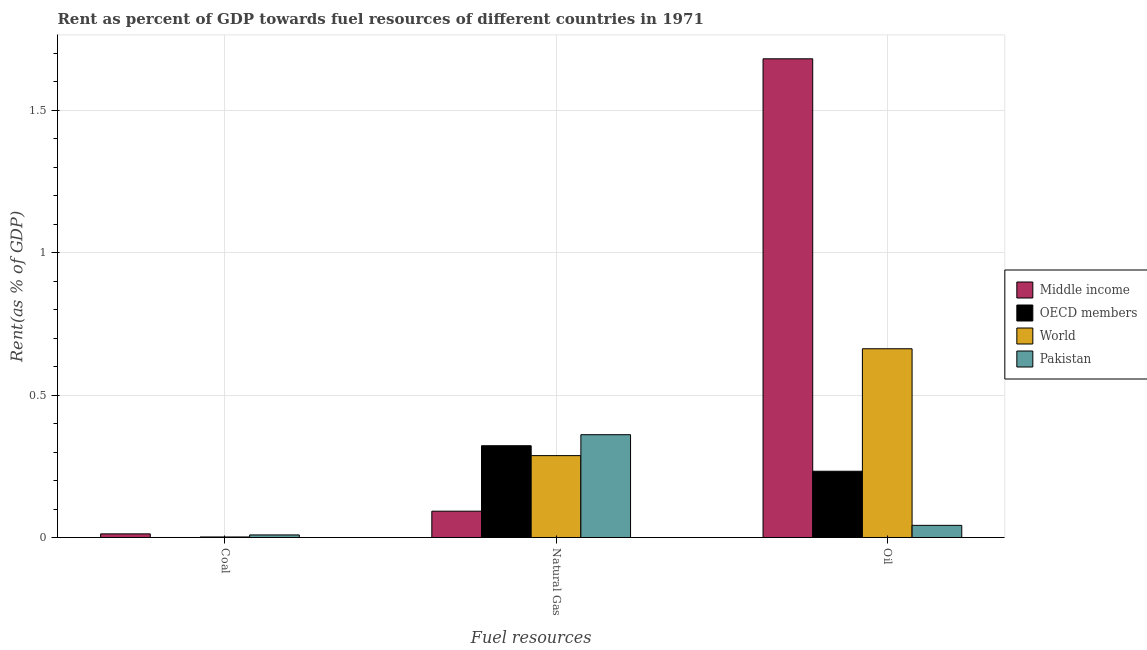How many different coloured bars are there?
Give a very brief answer. 4. How many groups of bars are there?
Your response must be concise. 3. Are the number of bars per tick equal to the number of legend labels?
Offer a very short reply. Yes. Are the number of bars on each tick of the X-axis equal?
Your answer should be very brief. Yes. How many bars are there on the 1st tick from the left?
Provide a short and direct response. 4. How many bars are there on the 2nd tick from the right?
Offer a very short reply. 4. What is the label of the 3rd group of bars from the left?
Keep it short and to the point. Oil. What is the rent towards coal in Middle income?
Give a very brief answer. 0.01. Across all countries, what is the maximum rent towards natural gas?
Give a very brief answer. 0.36. Across all countries, what is the minimum rent towards natural gas?
Keep it short and to the point. 0.09. In which country was the rent towards oil maximum?
Offer a very short reply. Middle income. What is the total rent towards natural gas in the graph?
Your response must be concise. 1.06. What is the difference between the rent towards oil in World and that in Pakistan?
Provide a succinct answer. 0.62. What is the difference between the rent towards oil in Middle income and the rent towards coal in Pakistan?
Offer a very short reply. 1.67. What is the average rent towards coal per country?
Keep it short and to the point. 0.01. What is the difference between the rent towards coal and rent towards oil in World?
Offer a terse response. -0.66. What is the ratio of the rent towards natural gas in World to that in OECD members?
Provide a short and direct response. 0.89. What is the difference between the highest and the second highest rent towards oil?
Your response must be concise. 1.02. What is the difference between the highest and the lowest rent towards coal?
Provide a succinct answer. 0.01. In how many countries, is the rent towards natural gas greater than the average rent towards natural gas taken over all countries?
Ensure brevity in your answer.  3. Is it the case that in every country, the sum of the rent towards coal and rent towards natural gas is greater than the rent towards oil?
Give a very brief answer. No. How many bars are there?
Your response must be concise. 12. Where does the legend appear in the graph?
Give a very brief answer. Center right. How many legend labels are there?
Provide a succinct answer. 4. How are the legend labels stacked?
Provide a short and direct response. Vertical. What is the title of the graph?
Provide a succinct answer. Rent as percent of GDP towards fuel resources of different countries in 1971. What is the label or title of the X-axis?
Your response must be concise. Fuel resources. What is the label or title of the Y-axis?
Provide a succinct answer. Rent(as % of GDP). What is the Rent(as % of GDP) of Middle income in Coal?
Provide a succinct answer. 0.01. What is the Rent(as % of GDP) in OECD members in Coal?
Your response must be concise. 1.83188177110096e-6. What is the Rent(as % of GDP) of World in Coal?
Offer a terse response. 0. What is the Rent(as % of GDP) of Pakistan in Coal?
Keep it short and to the point. 0.01. What is the Rent(as % of GDP) of Middle income in Natural Gas?
Provide a short and direct response. 0.09. What is the Rent(as % of GDP) of OECD members in Natural Gas?
Keep it short and to the point. 0.32. What is the Rent(as % of GDP) of World in Natural Gas?
Your answer should be compact. 0.29. What is the Rent(as % of GDP) of Pakistan in Natural Gas?
Your answer should be very brief. 0.36. What is the Rent(as % of GDP) in Middle income in Oil?
Give a very brief answer. 1.68. What is the Rent(as % of GDP) of OECD members in Oil?
Offer a very short reply. 0.23. What is the Rent(as % of GDP) of World in Oil?
Provide a succinct answer. 0.66. What is the Rent(as % of GDP) of Pakistan in Oil?
Keep it short and to the point. 0.04. Across all Fuel resources, what is the maximum Rent(as % of GDP) of Middle income?
Offer a very short reply. 1.68. Across all Fuel resources, what is the maximum Rent(as % of GDP) of OECD members?
Your answer should be compact. 0.32. Across all Fuel resources, what is the maximum Rent(as % of GDP) of World?
Make the answer very short. 0.66. Across all Fuel resources, what is the maximum Rent(as % of GDP) of Pakistan?
Offer a very short reply. 0.36. Across all Fuel resources, what is the minimum Rent(as % of GDP) of Middle income?
Provide a short and direct response. 0.01. Across all Fuel resources, what is the minimum Rent(as % of GDP) in OECD members?
Your response must be concise. 1.83188177110096e-6. Across all Fuel resources, what is the minimum Rent(as % of GDP) of World?
Provide a succinct answer. 0. Across all Fuel resources, what is the minimum Rent(as % of GDP) in Pakistan?
Provide a succinct answer. 0.01. What is the total Rent(as % of GDP) of Middle income in the graph?
Offer a terse response. 1.79. What is the total Rent(as % of GDP) in OECD members in the graph?
Provide a succinct answer. 0.55. What is the total Rent(as % of GDP) in World in the graph?
Offer a terse response. 0.95. What is the total Rent(as % of GDP) of Pakistan in the graph?
Offer a very short reply. 0.41. What is the difference between the Rent(as % of GDP) of Middle income in Coal and that in Natural Gas?
Your answer should be very brief. -0.08. What is the difference between the Rent(as % of GDP) of OECD members in Coal and that in Natural Gas?
Provide a short and direct response. -0.32. What is the difference between the Rent(as % of GDP) of World in Coal and that in Natural Gas?
Give a very brief answer. -0.29. What is the difference between the Rent(as % of GDP) in Pakistan in Coal and that in Natural Gas?
Offer a very short reply. -0.35. What is the difference between the Rent(as % of GDP) of Middle income in Coal and that in Oil?
Make the answer very short. -1.67. What is the difference between the Rent(as % of GDP) of OECD members in Coal and that in Oil?
Offer a very short reply. -0.23. What is the difference between the Rent(as % of GDP) in World in Coal and that in Oil?
Ensure brevity in your answer.  -0.66. What is the difference between the Rent(as % of GDP) of Pakistan in Coal and that in Oil?
Keep it short and to the point. -0.03. What is the difference between the Rent(as % of GDP) in Middle income in Natural Gas and that in Oil?
Give a very brief answer. -1.59. What is the difference between the Rent(as % of GDP) in OECD members in Natural Gas and that in Oil?
Keep it short and to the point. 0.09. What is the difference between the Rent(as % of GDP) in World in Natural Gas and that in Oil?
Your answer should be compact. -0.38. What is the difference between the Rent(as % of GDP) of Pakistan in Natural Gas and that in Oil?
Offer a very short reply. 0.32. What is the difference between the Rent(as % of GDP) of Middle income in Coal and the Rent(as % of GDP) of OECD members in Natural Gas?
Your answer should be compact. -0.31. What is the difference between the Rent(as % of GDP) in Middle income in Coal and the Rent(as % of GDP) in World in Natural Gas?
Offer a very short reply. -0.27. What is the difference between the Rent(as % of GDP) in Middle income in Coal and the Rent(as % of GDP) in Pakistan in Natural Gas?
Give a very brief answer. -0.35. What is the difference between the Rent(as % of GDP) of OECD members in Coal and the Rent(as % of GDP) of World in Natural Gas?
Provide a succinct answer. -0.29. What is the difference between the Rent(as % of GDP) of OECD members in Coal and the Rent(as % of GDP) of Pakistan in Natural Gas?
Provide a short and direct response. -0.36. What is the difference between the Rent(as % of GDP) of World in Coal and the Rent(as % of GDP) of Pakistan in Natural Gas?
Give a very brief answer. -0.36. What is the difference between the Rent(as % of GDP) in Middle income in Coal and the Rent(as % of GDP) in OECD members in Oil?
Offer a very short reply. -0.22. What is the difference between the Rent(as % of GDP) in Middle income in Coal and the Rent(as % of GDP) in World in Oil?
Ensure brevity in your answer.  -0.65. What is the difference between the Rent(as % of GDP) of Middle income in Coal and the Rent(as % of GDP) of Pakistan in Oil?
Provide a succinct answer. -0.03. What is the difference between the Rent(as % of GDP) in OECD members in Coal and the Rent(as % of GDP) in World in Oil?
Your answer should be very brief. -0.66. What is the difference between the Rent(as % of GDP) of OECD members in Coal and the Rent(as % of GDP) of Pakistan in Oil?
Offer a very short reply. -0.04. What is the difference between the Rent(as % of GDP) of World in Coal and the Rent(as % of GDP) of Pakistan in Oil?
Ensure brevity in your answer.  -0.04. What is the difference between the Rent(as % of GDP) of Middle income in Natural Gas and the Rent(as % of GDP) of OECD members in Oil?
Your answer should be compact. -0.14. What is the difference between the Rent(as % of GDP) in Middle income in Natural Gas and the Rent(as % of GDP) in World in Oil?
Make the answer very short. -0.57. What is the difference between the Rent(as % of GDP) of Middle income in Natural Gas and the Rent(as % of GDP) of Pakistan in Oil?
Your answer should be compact. 0.05. What is the difference between the Rent(as % of GDP) in OECD members in Natural Gas and the Rent(as % of GDP) in World in Oil?
Offer a very short reply. -0.34. What is the difference between the Rent(as % of GDP) in OECD members in Natural Gas and the Rent(as % of GDP) in Pakistan in Oil?
Your response must be concise. 0.28. What is the difference between the Rent(as % of GDP) of World in Natural Gas and the Rent(as % of GDP) of Pakistan in Oil?
Make the answer very short. 0.24. What is the average Rent(as % of GDP) of Middle income per Fuel resources?
Provide a short and direct response. 0.6. What is the average Rent(as % of GDP) in OECD members per Fuel resources?
Make the answer very short. 0.18. What is the average Rent(as % of GDP) in World per Fuel resources?
Your response must be concise. 0.32. What is the average Rent(as % of GDP) in Pakistan per Fuel resources?
Keep it short and to the point. 0.14. What is the difference between the Rent(as % of GDP) of Middle income and Rent(as % of GDP) of OECD members in Coal?
Give a very brief answer. 0.01. What is the difference between the Rent(as % of GDP) of Middle income and Rent(as % of GDP) of World in Coal?
Your response must be concise. 0.01. What is the difference between the Rent(as % of GDP) in Middle income and Rent(as % of GDP) in Pakistan in Coal?
Keep it short and to the point. 0. What is the difference between the Rent(as % of GDP) of OECD members and Rent(as % of GDP) of World in Coal?
Offer a very short reply. -0. What is the difference between the Rent(as % of GDP) of OECD members and Rent(as % of GDP) of Pakistan in Coal?
Make the answer very short. -0.01. What is the difference between the Rent(as % of GDP) of World and Rent(as % of GDP) of Pakistan in Coal?
Ensure brevity in your answer.  -0.01. What is the difference between the Rent(as % of GDP) in Middle income and Rent(as % of GDP) in OECD members in Natural Gas?
Your answer should be compact. -0.23. What is the difference between the Rent(as % of GDP) in Middle income and Rent(as % of GDP) in World in Natural Gas?
Keep it short and to the point. -0.2. What is the difference between the Rent(as % of GDP) in Middle income and Rent(as % of GDP) in Pakistan in Natural Gas?
Keep it short and to the point. -0.27. What is the difference between the Rent(as % of GDP) of OECD members and Rent(as % of GDP) of World in Natural Gas?
Offer a very short reply. 0.03. What is the difference between the Rent(as % of GDP) of OECD members and Rent(as % of GDP) of Pakistan in Natural Gas?
Make the answer very short. -0.04. What is the difference between the Rent(as % of GDP) of World and Rent(as % of GDP) of Pakistan in Natural Gas?
Offer a terse response. -0.07. What is the difference between the Rent(as % of GDP) of Middle income and Rent(as % of GDP) of OECD members in Oil?
Make the answer very short. 1.45. What is the difference between the Rent(as % of GDP) of Middle income and Rent(as % of GDP) of World in Oil?
Your answer should be very brief. 1.02. What is the difference between the Rent(as % of GDP) of Middle income and Rent(as % of GDP) of Pakistan in Oil?
Your answer should be very brief. 1.64. What is the difference between the Rent(as % of GDP) in OECD members and Rent(as % of GDP) in World in Oil?
Ensure brevity in your answer.  -0.43. What is the difference between the Rent(as % of GDP) of OECD members and Rent(as % of GDP) of Pakistan in Oil?
Your response must be concise. 0.19. What is the difference between the Rent(as % of GDP) in World and Rent(as % of GDP) in Pakistan in Oil?
Ensure brevity in your answer.  0.62. What is the ratio of the Rent(as % of GDP) in Middle income in Coal to that in Natural Gas?
Ensure brevity in your answer.  0.14. What is the ratio of the Rent(as % of GDP) in OECD members in Coal to that in Natural Gas?
Keep it short and to the point. 0. What is the ratio of the Rent(as % of GDP) of World in Coal to that in Natural Gas?
Ensure brevity in your answer.  0.01. What is the ratio of the Rent(as % of GDP) of Pakistan in Coal to that in Natural Gas?
Provide a short and direct response. 0.02. What is the ratio of the Rent(as % of GDP) in Middle income in Coal to that in Oil?
Offer a very short reply. 0.01. What is the ratio of the Rent(as % of GDP) of World in Coal to that in Oil?
Offer a terse response. 0. What is the ratio of the Rent(as % of GDP) of Pakistan in Coal to that in Oil?
Ensure brevity in your answer.  0.21. What is the ratio of the Rent(as % of GDP) in Middle income in Natural Gas to that in Oil?
Your answer should be very brief. 0.06. What is the ratio of the Rent(as % of GDP) of OECD members in Natural Gas to that in Oil?
Ensure brevity in your answer.  1.39. What is the ratio of the Rent(as % of GDP) in World in Natural Gas to that in Oil?
Your answer should be very brief. 0.43. What is the ratio of the Rent(as % of GDP) in Pakistan in Natural Gas to that in Oil?
Your answer should be compact. 8.47. What is the difference between the highest and the second highest Rent(as % of GDP) in Middle income?
Offer a terse response. 1.59. What is the difference between the highest and the second highest Rent(as % of GDP) of OECD members?
Provide a succinct answer. 0.09. What is the difference between the highest and the second highest Rent(as % of GDP) of World?
Your answer should be very brief. 0.38. What is the difference between the highest and the second highest Rent(as % of GDP) of Pakistan?
Ensure brevity in your answer.  0.32. What is the difference between the highest and the lowest Rent(as % of GDP) of Middle income?
Provide a succinct answer. 1.67. What is the difference between the highest and the lowest Rent(as % of GDP) in OECD members?
Offer a terse response. 0.32. What is the difference between the highest and the lowest Rent(as % of GDP) of World?
Ensure brevity in your answer.  0.66. What is the difference between the highest and the lowest Rent(as % of GDP) of Pakistan?
Provide a short and direct response. 0.35. 